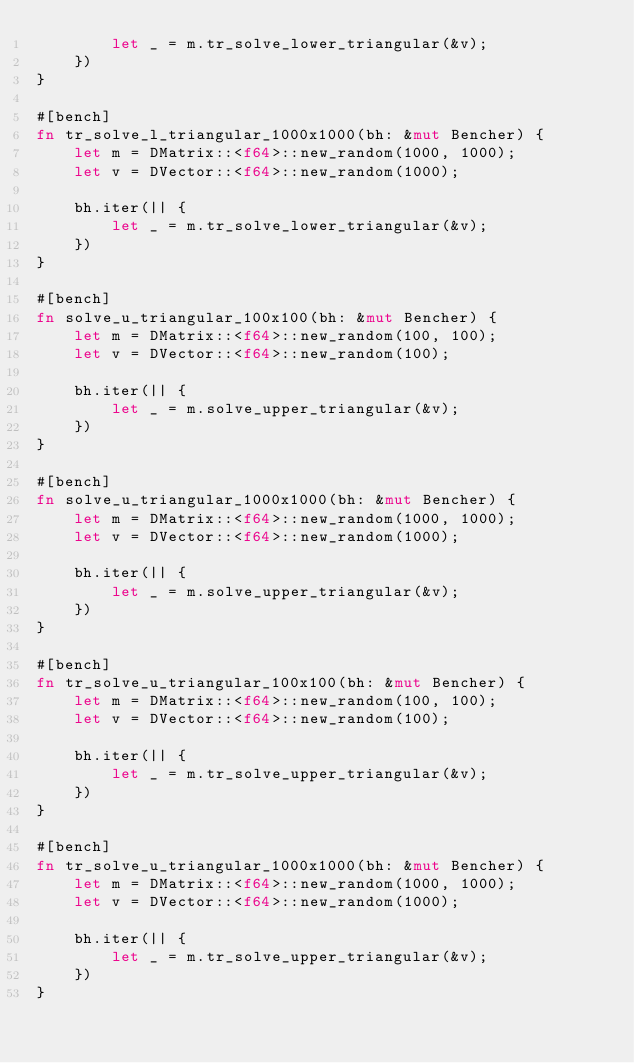Convert code to text. <code><loc_0><loc_0><loc_500><loc_500><_Rust_>        let _ = m.tr_solve_lower_triangular(&v);
    })
}

#[bench]
fn tr_solve_l_triangular_1000x1000(bh: &mut Bencher) {
    let m = DMatrix::<f64>::new_random(1000, 1000);
    let v = DVector::<f64>::new_random(1000);

    bh.iter(|| {
        let _ = m.tr_solve_lower_triangular(&v);
    })
}

#[bench]
fn solve_u_triangular_100x100(bh: &mut Bencher) {
    let m = DMatrix::<f64>::new_random(100, 100);
    let v = DVector::<f64>::new_random(100);

    bh.iter(|| {
        let _ = m.solve_upper_triangular(&v);
    })
}

#[bench]
fn solve_u_triangular_1000x1000(bh: &mut Bencher) {
    let m = DMatrix::<f64>::new_random(1000, 1000);
    let v = DVector::<f64>::new_random(1000);

    bh.iter(|| {
        let _ = m.solve_upper_triangular(&v);
    })
}

#[bench]
fn tr_solve_u_triangular_100x100(bh: &mut Bencher) {
    let m = DMatrix::<f64>::new_random(100, 100);
    let v = DVector::<f64>::new_random(100);

    bh.iter(|| {
        let _ = m.tr_solve_upper_triangular(&v);
    })
}

#[bench]
fn tr_solve_u_triangular_1000x1000(bh: &mut Bencher) {
    let m = DMatrix::<f64>::new_random(1000, 1000);
    let v = DVector::<f64>::new_random(1000);

    bh.iter(|| {
        let _ = m.tr_solve_upper_triangular(&v);
    })
}
</code> 